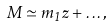Convert formula to latex. <formula><loc_0><loc_0><loc_500><loc_500>M \simeq m _ { 1 } z + \hdots ,</formula> 